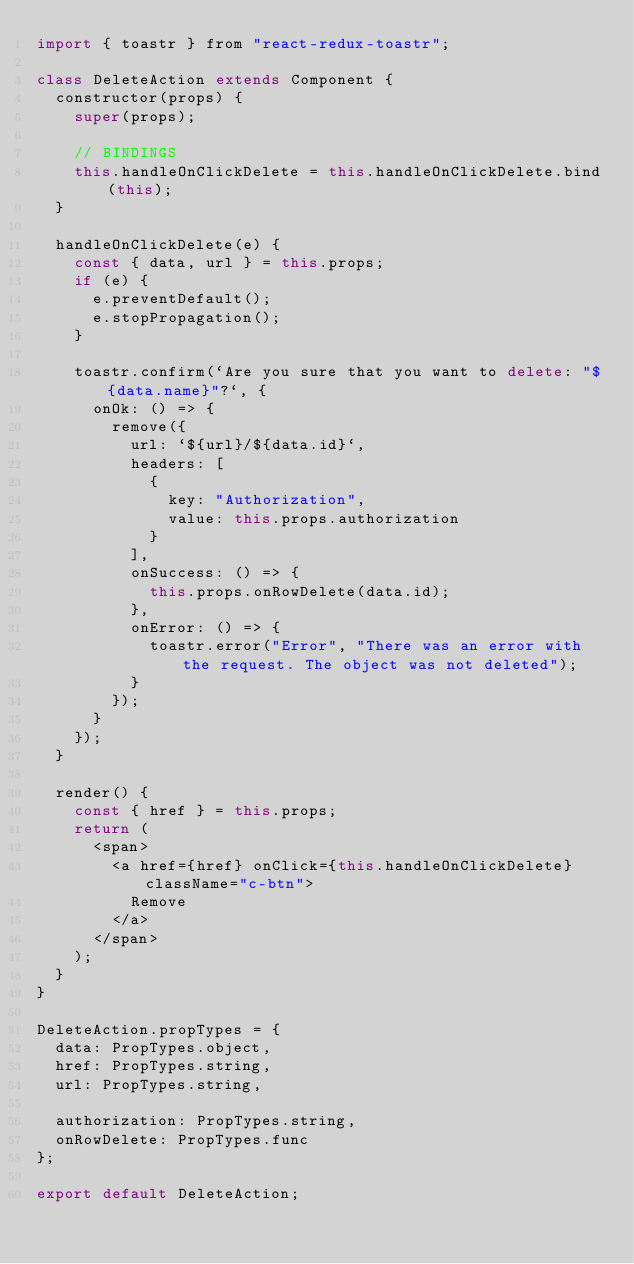Convert code to text. <code><loc_0><loc_0><loc_500><loc_500><_JavaScript_>import { toastr } from "react-redux-toastr";

class DeleteAction extends Component {
  constructor(props) {
    super(props);

    // BINDINGS
    this.handleOnClickDelete = this.handleOnClickDelete.bind(this);
  }

  handleOnClickDelete(e) {
    const { data, url } = this.props;
    if (e) {
      e.preventDefault();
      e.stopPropagation();
    }

    toastr.confirm(`Are you sure that you want to delete: "${data.name}"?`, {
      onOk: () => {
        remove({
          url: `${url}/${data.id}`,
          headers: [
            {
              key: "Authorization",
              value: this.props.authorization
            }
          ],
          onSuccess: () => {
            this.props.onRowDelete(data.id);
          },
          onError: () => {
            toastr.error("Error", "There was an error with the request. The object was not deleted");
          }
        });
      }
    });
  }

  render() {
    const { href } = this.props;
    return (
      <span>
        <a href={href} onClick={this.handleOnClickDelete} className="c-btn">
          Remove
        </a>
      </span>
    );
  }
}

DeleteAction.propTypes = {
  data: PropTypes.object,
  href: PropTypes.string,
  url: PropTypes.string,

  authorization: PropTypes.string,
  onRowDelete: PropTypes.func
};

export default DeleteAction;
</code> 